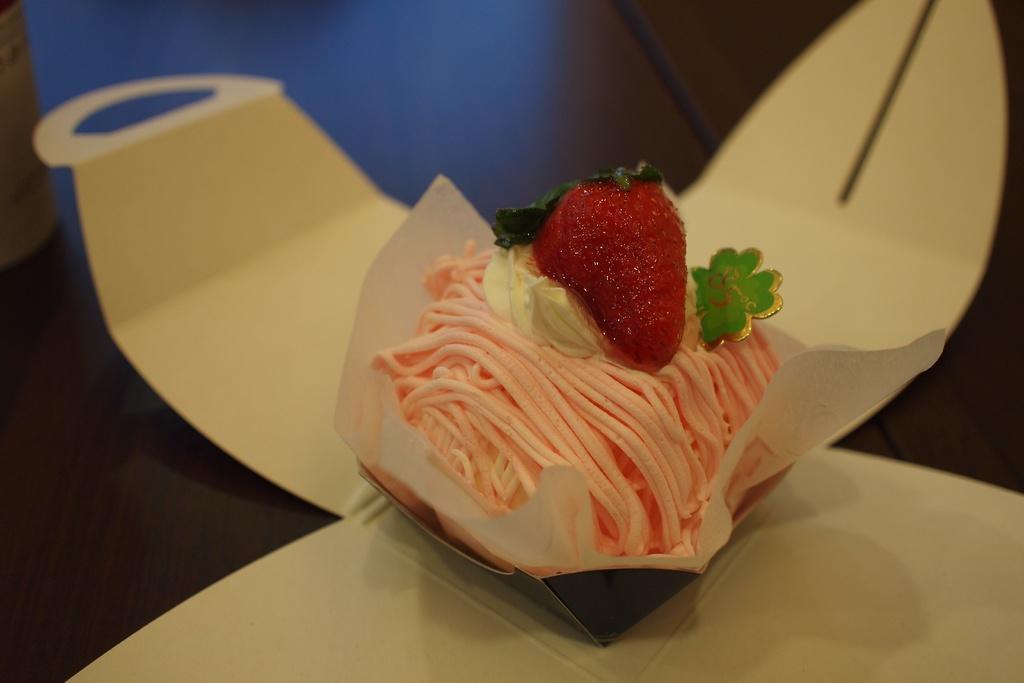In one or two sentences, can you explain what this image depicts? In this image in the center there is one box and there is one pastry, at the bottom there is a table. 